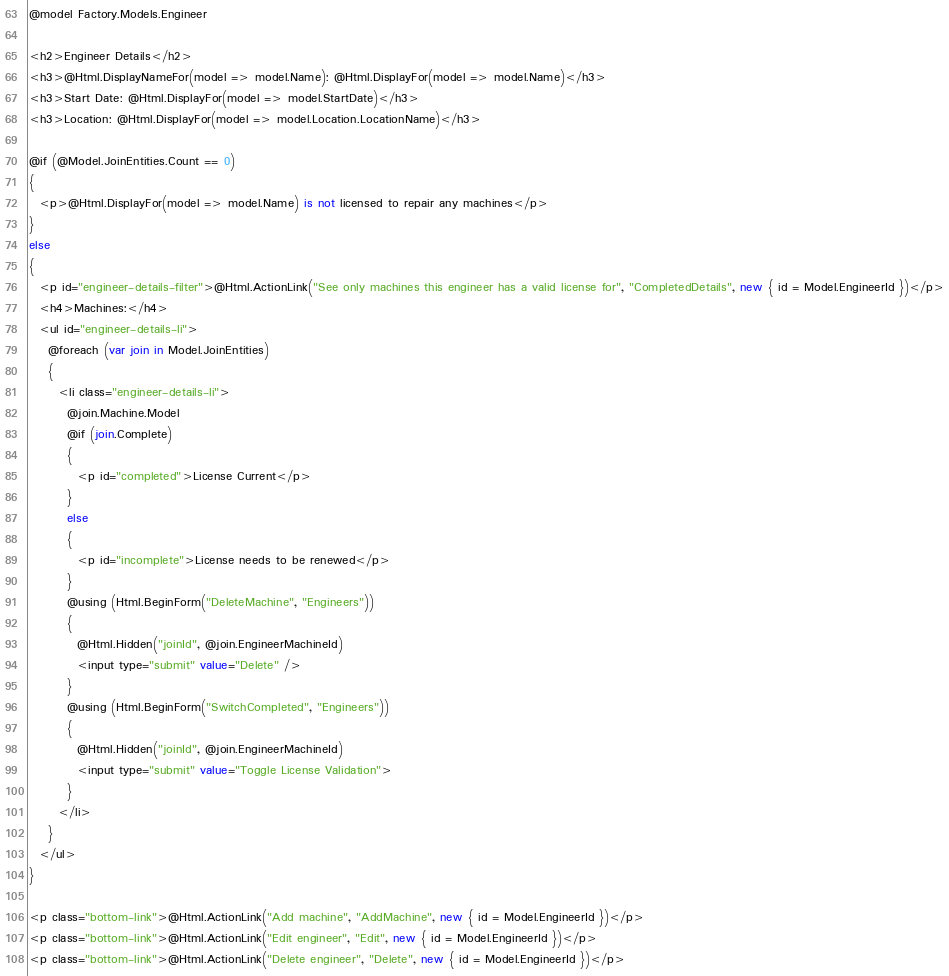<code> <loc_0><loc_0><loc_500><loc_500><_C#_>@model Factory.Models.Engineer

<h2>Engineer Details</h2>
<h3>@Html.DisplayNameFor(model => model.Name): @Html.DisplayFor(model => model.Name)</h3>
<h3>Start Date: @Html.DisplayFor(model => model.StartDate)</h3>
<h3>Location: @Html.DisplayFor(model => model.Location.LocationName)</h3>

@if (@Model.JoinEntities.Count == 0)
{
  <p>@Html.DisplayFor(model => model.Name) is not licensed to repair any machines</p>
}
else
{
  <p id="engineer-details-filter">@Html.ActionLink("See only machines this engineer has a valid license for", "CompletedDetails", new { id = Model.EngineerId })</p>
  <h4>Machines:</h4>
  <ul id="engineer-details-li">
    @foreach (var join in Model.JoinEntities)
    {
      <li class="engineer-details-li">
        @join.Machine.Model
        @if (join.Complete)
        {
          <p id="completed">License Current</p>
        }
        else
        {
          <p id="incomplete">License needs to be renewed</p>
        }
        @using (Html.BeginForm("DeleteMachine", "Engineers"))
        {
          @Html.Hidden("joinId", @join.EngineerMachineId)
          <input type="submit" value="Delete" />
        }
        @using (Html.BeginForm("SwitchCompleted", "Engineers"))
        {
          @Html.Hidden("joinId", @join.EngineerMachineId)
          <input type="submit" value="Toggle License Validation">
        }
      </li>
    }
  </ul>
}

<p class="bottom-link">@Html.ActionLink("Add machine", "AddMachine", new { id = Model.EngineerId })</p>
<p class="bottom-link">@Html.ActionLink("Edit engineer", "Edit", new { id = Model.EngineerId })</p>
<p class="bottom-link">@Html.ActionLink("Delete engineer", "Delete", new { id = Model.EngineerId })</p></code> 